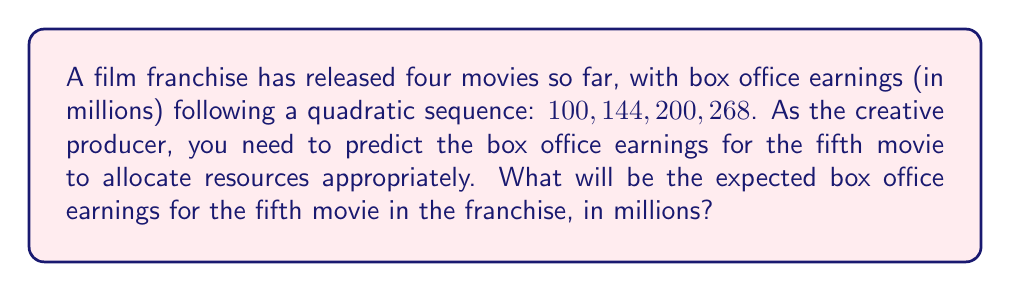Give your solution to this math problem. Let's approach this step-by-step:

1) First, we need to find the quadratic sequence formula. The general form is:

   $$a_n = an^2 + bn + c$$

   where $n$ is the term number (1, 2, 3, ...) and $a$, $b$, and $c$ are constants we need to determine.

2) We have four known terms:
   $$a_1 = 100$$
   $$a_2 = 144$$
   $$a_3 = 200$$
   $$a_4 = 268$$

3) Let's substitute these into our general formula:
   $$100 = a(1)^2 + b(1) + c$$
   $$144 = a(2)^2 + b(2) + c$$
   $$200 = a(3)^2 + b(3) + c$$
   $$268 = a(4)^2 + b(4) + c$$

4) Subtracting consecutive equations:
   $$144 - 100 = 44 = 3a + b$$
   $$200 - 144 = 56 = 5a + b$$
   $$268 - 200 = 68 = 7a + b$$

5) From these, we can deduce:
   $$56 - 44 = 12 = 2a$$
   $$68 - 56 = 12 = 2a$$

   So, $a = 6$

6) Substituting back:
   $$44 = 3(6) + b$$
   $$44 = 18 + b$$
   $$b = 26$$

7) Now we can find $c$ using the first equation:
   $$100 = 6(1) + 26(1) + c$$
   $$100 = 32 + c$$
   $$c = 68$$

8) Our sequence formula is thus:
   $$a_n = 6n^2 + 26n + 68$$

9) For the fifth movie, $n = 5$:
   $$a_5 = 6(5)^2 + 26(5) + 68$$
   $$a_5 = 6(25) + 130 + 68$$
   $$a_5 = 150 + 130 + 68$$
   $$a_5 = 348$$

Therefore, the expected box office earnings for the fifth movie would be $348 million.
Answer: $348 million 